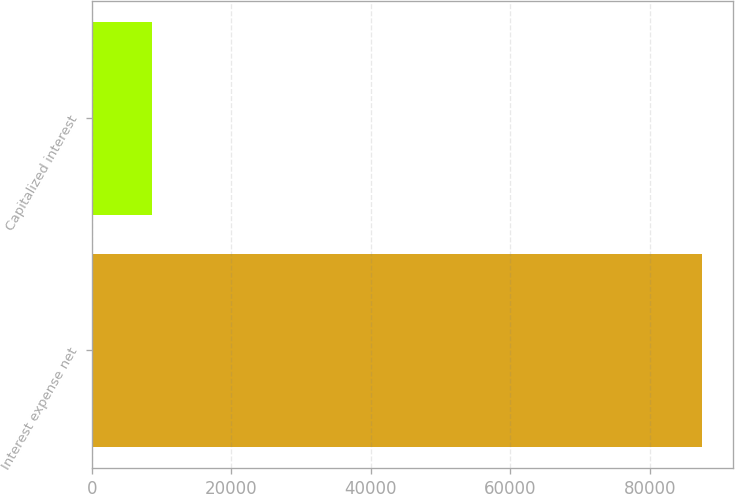<chart> <loc_0><loc_0><loc_500><loc_500><bar_chart><fcel>Interest expense net<fcel>Capitalized interest<nl><fcel>87541<fcel>8684<nl></chart> 